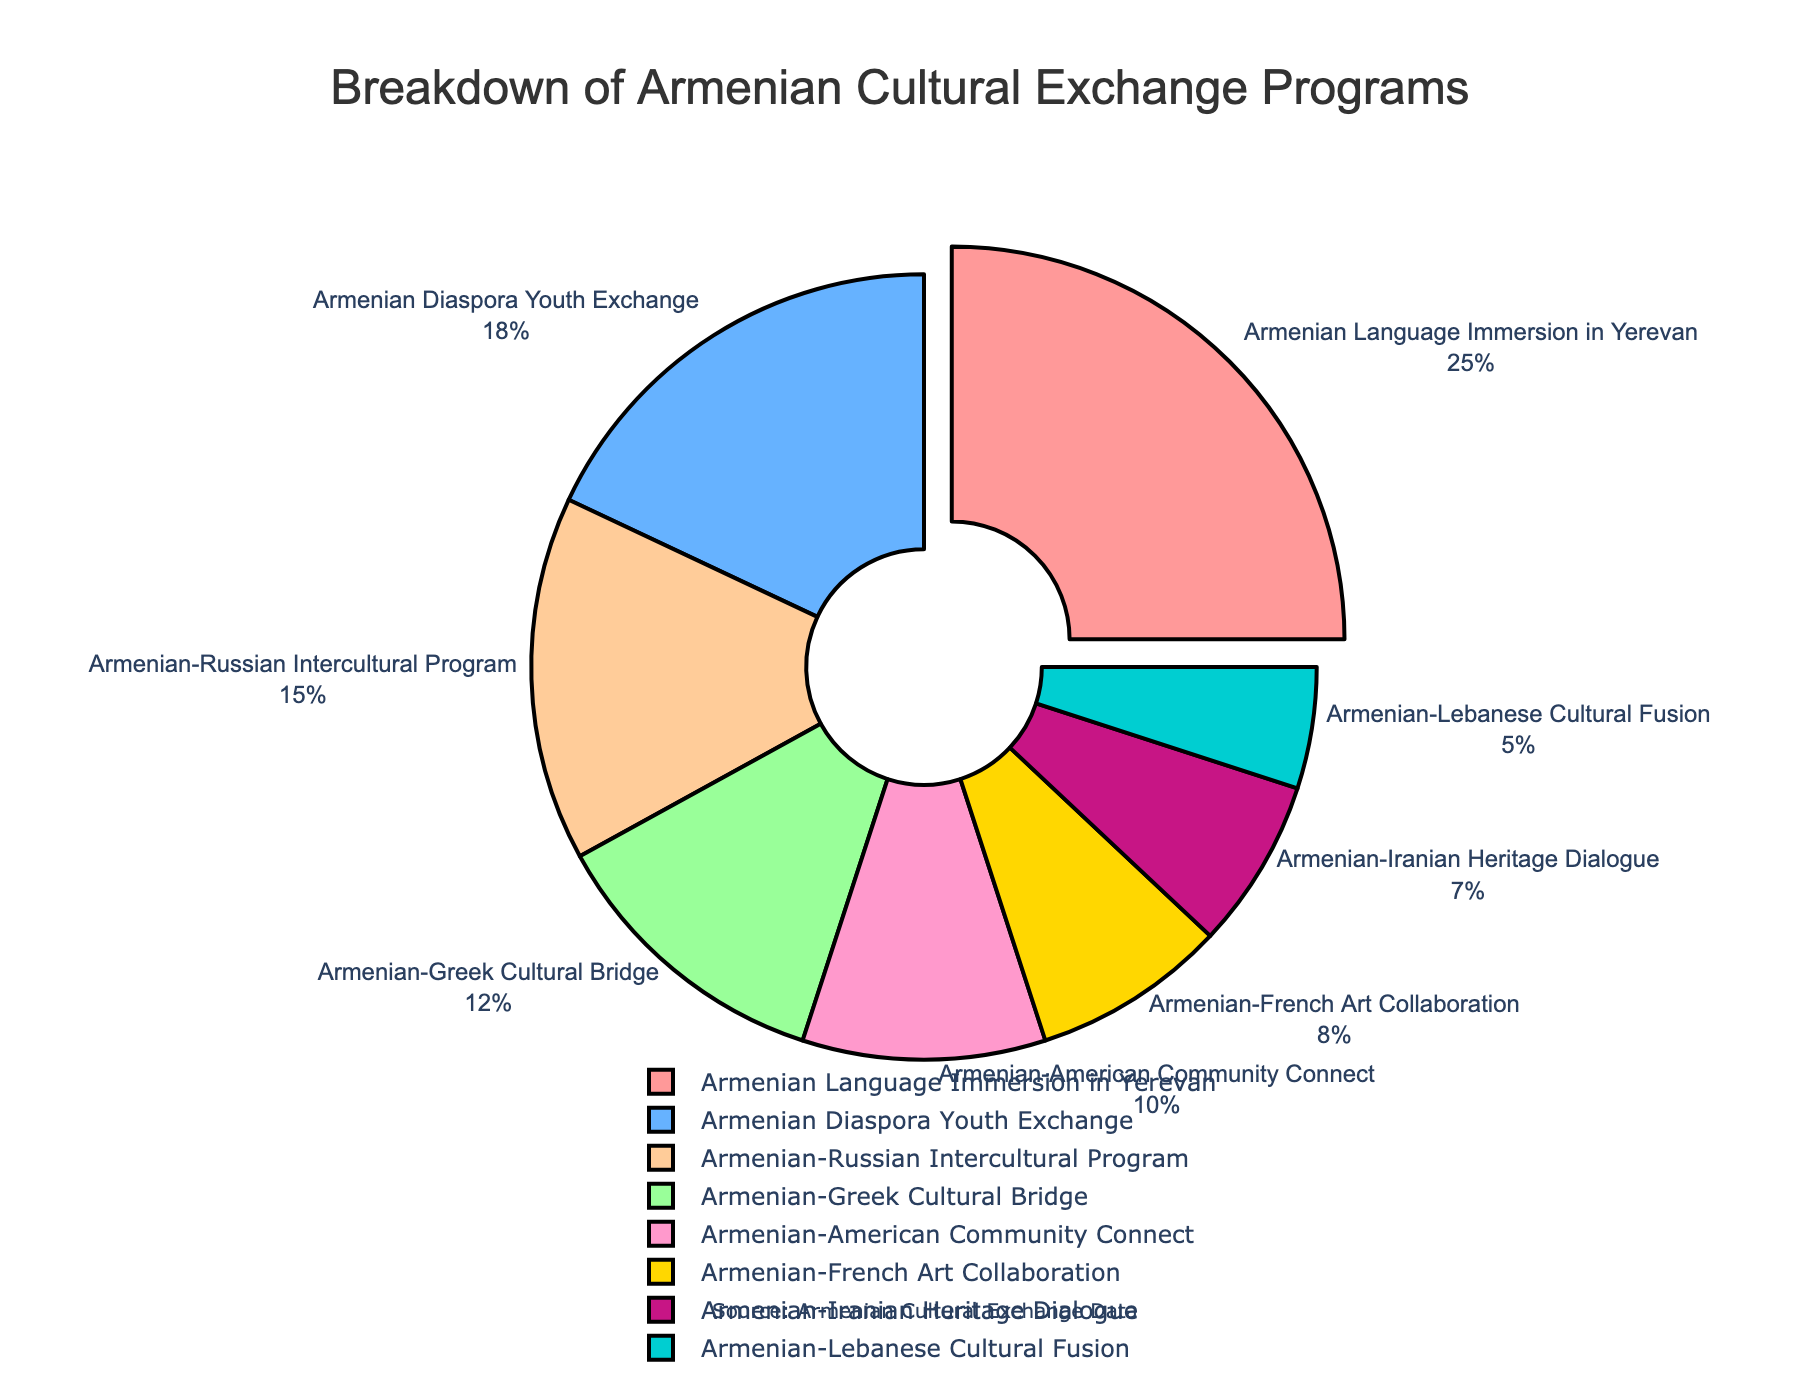Which program type has the highest percentage of participation? By examining the pie chart, the segment labeled "Armenian Language Immersion in Yerevan" occupies the largest portion. This indicates it has the highest percentage of participation.
Answer: Armenian Language Immersion in Yerevan How many more percentage points does the Armenian Language Immersion in Yerevan have compared to the Armenian Diaspora Youth Exchange? The Armenian Language Immersion in Yerevan has 25%, and the Armenian Diaspora Youth Exchange has 18%. The difference is 25% - 18% = 7%.
Answer: 7% What is the total percentage of programs involving Armenian-French Art Collaboration and Armenian-Iranian Heritage Dialogue? Sum the percentages of Armenian-French Art Collaboration (8%) and Armenian-Iranian Heritage Dialogue (7%) to get 8% + 7% = 15%.
Answer: 15% How does the percentage of Armenian-Lebanese Cultural Fusion compare to the Armenian-Amercan Community Connect? The Armenian-Lebanese Cultural Fusion has 5%, and the Armenian-American Community Connect has 10%. The Armenian-American Community Connect is double (10% compared to 5%).
Answer: Armenian-American Community Connect is double What is the combined percentage of programs with a focus on arts and culture (Armenian-French Art Collaboration) and language immersion (Armenian Language Immersion in Yerevan)? Sum the percentages of Armenian-French Art Collaboration (8%) and Armenian Language Immersion in Yerevan (25%) to get 8% + 25% = 33%.
Answer: 33% Which color represents the Armenian-Greek Cultural Bridge program, and what percentage does it represent? The Armenian-Greek Cultural Bridge program is represented by a green color in the pie chart, and it makes up 12% of the total.
Answer: Green, 12% What is the difference in percentage points between the Armenian-Russian Intercultural Program and the Armenian-Iranian Heritage Dialogue? The Armenian-Russian Intercultural Program is 15%, and the Armenian-Iranian Heritage Dialogue is 7%. The difference is 15% - 7% = 8%.
Answer: 8% What is the average percentage of all the programs listed? Sum all the percentages: 25 + 18 + 12 + 15 + 10 + 8 + 7 + 5 = 100. There are 8 programs, so the average is 100 / 8 = 12.5%.
Answer: 12.5% 